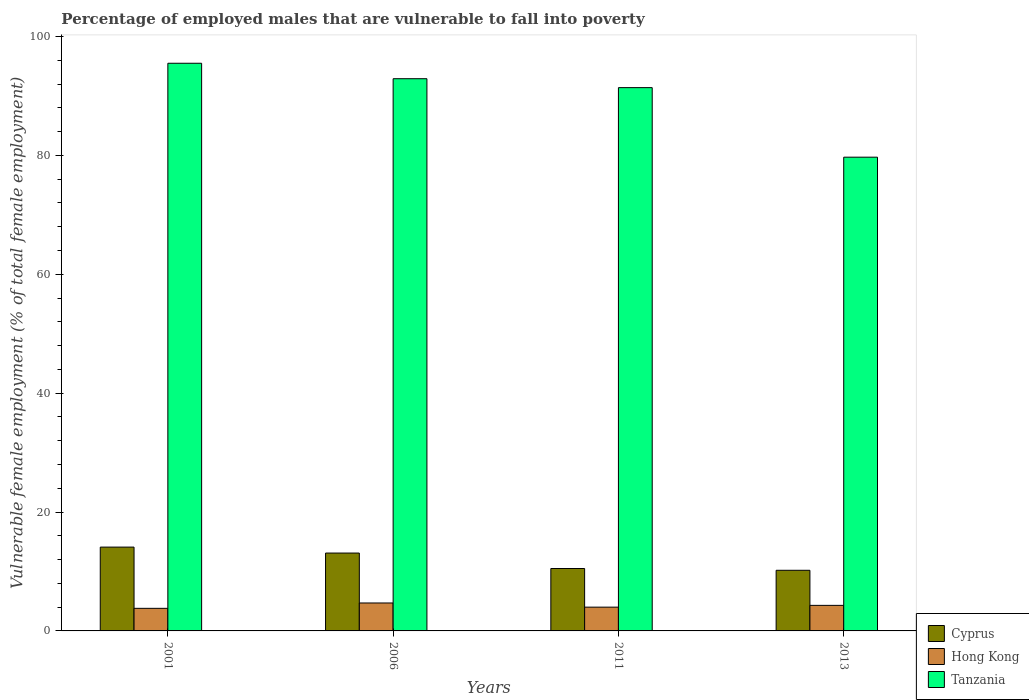How many different coloured bars are there?
Keep it short and to the point. 3. How many groups of bars are there?
Offer a terse response. 4. Are the number of bars on each tick of the X-axis equal?
Ensure brevity in your answer.  Yes. How many bars are there on the 3rd tick from the left?
Keep it short and to the point. 3. How many bars are there on the 4th tick from the right?
Provide a short and direct response. 3. What is the label of the 3rd group of bars from the left?
Offer a very short reply. 2011. In how many cases, is the number of bars for a given year not equal to the number of legend labels?
Give a very brief answer. 0. What is the percentage of employed males who are vulnerable to fall into poverty in Tanzania in 2013?
Give a very brief answer. 79.7. Across all years, what is the maximum percentage of employed males who are vulnerable to fall into poverty in Hong Kong?
Ensure brevity in your answer.  4.7. Across all years, what is the minimum percentage of employed males who are vulnerable to fall into poverty in Hong Kong?
Provide a succinct answer. 3.8. What is the total percentage of employed males who are vulnerable to fall into poverty in Cyprus in the graph?
Provide a succinct answer. 47.9. What is the difference between the percentage of employed males who are vulnerable to fall into poverty in Tanzania in 2006 and that in 2013?
Provide a succinct answer. 13.2. What is the difference between the percentage of employed males who are vulnerable to fall into poverty in Tanzania in 2006 and the percentage of employed males who are vulnerable to fall into poverty in Hong Kong in 2013?
Make the answer very short. 88.6. What is the average percentage of employed males who are vulnerable to fall into poverty in Cyprus per year?
Your answer should be compact. 11.98. In the year 2006, what is the difference between the percentage of employed males who are vulnerable to fall into poverty in Hong Kong and percentage of employed males who are vulnerable to fall into poverty in Tanzania?
Provide a short and direct response. -88.2. What is the ratio of the percentage of employed males who are vulnerable to fall into poverty in Hong Kong in 2011 to that in 2013?
Your answer should be compact. 0.93. Is the difference between the percentage of employed males who are vulnerable to fall into poverty in Hong Kong in 2001 and 2013 greater than the difference between the percentage of employed males who are vulnerable to fall into poverty in Tanzania in 2001 and 2013?
Offer a terse response. No. What is the difference between the highest and the second highest percentage of employed males who are vulnerable to fall into poverty in Hong Kong?
Offer a very short reply. 0.4. What is the difference between the highest and the lowest percentage of employed males who are vulnerable to fall into poverty in Hong Kong?
Your response must be concise. 0.9. Is the sum of the percentage of employed males who are vulnerable to fall into poverty in Hong Kong in 2006 and 2011 greater than the maximum percentage of employed males who are vulnerable to fall into poverty in Tanzania across all years?
Give a very brief answer. No. What does the 1st bar from the left in 2013 represents?
Your response must be concise. Cyprus. What does the 3rd bar from the right in 2011 represents?
Keep it short and to the point. Cyprus. Is it the case that in every year, the sum of the percentage of employed males who are vulnerable to fall into poverty in Tanzania and percentage of employed males who are vulnerable to fall into poverty in Cyprus is greater than the percentage of employed males who are vulnerable to fall into poverty in Hong Kong?
Your answer should be very brief. Yes. How many years are there in the graph?
Keep it short and to the point. 4. What is the difference between two consecutive major ticks on the Y-axis?
Provide a short and direct response. 20. Where does the legend appear in the graph?
Offer a terse response. Bottom right. How many legend labels are there?
Provide a succinct answer. 3. How are the legend labels stacked?
Provide a succinct answer. Vertical. What is the title of the graph?
Your response must be concise. Percentage of employed males that are vulnerable to fall into poverty. What is the label or title of the Y-axis?
Provide a succinct answer. Vulnerable female employment (% of total female employment). What is the Vulnerable female employment (% of total female employment) in Cyprus in 2001?
Your answer should be compact. 14.1. What is the Vulnerable female employment (% of total female employment) of Hong Kong in 2001?
Provide a short and direct response. 3.8. What is the Vulnerable female employment (% of total female employment) of Tanzania in 2001?
Your response must be concise. 95.5. What is the Vulnerable female employment (% of total female employment) in Cyprus in 2006?
Offer a very short reply. 13.1. What is the Vulnerable female employment (% of total female employment) in Hong Kong in 2006?
Keep it short and to the point. 4.7. What is the Vulnerable female employment (% of total female employment) in Tanzania in 2006?
Your response must be concise. 92.9. What is the Vulnerable female employment (% of total female employment) of Cyprus in 2011?
Offer a very short reply. 10.5. What is the Vulnerable female employment (% of total female employment) of Hong Kong in 2011?
Keep it short and to the point. 4. What is the Vulnerable female employment (% of total female employment) in Tanzania in 2011?
Give a very brief answer. 91.4. What is the Vulnerable female employment (% of total female employment) in Cyprus in 2013?
Your answer should be very brief. 10.2. What is the Vulnerable female employment (% of total female employment) of Hong Kong in 2013?
Provide a short and direct response. 4.3. What is the Vulnerable female employment (% of total female employment) of Tanzania in 2013?
Offer a very short reply. 79.7. Across all years, what is the maximum Vulnerable female employment (% of total female employment) of Cyprus?
Your response must be concise. 14.1. Across all years, what is the maximum Vulnerable female employment (% of total female employment) of Hong Kong?
Your answer should be compact. 4.7. Across all years, what is the maximum Vulnerable female employment (% of total female employment) in Tanzania?
Keep it short and to the point. 95.5. Across all years, what is the minimum Vulnerable female employment (% of total female employment) in Cyprus?
Provide a short and direct response. 10.2. Across all years, what is the minimum Vulnerable female employment (% of total female employment) in Hong Kong?
Your response must be concise. 3.8. Across all years, what is the minimum Vulnerable female employment (% of total female employment) in Tanzania?
Keep it short and to the point. 79.7. What is the total Vulnerable female employment (% of total female employment) of Cyprus in the graph?
Keep it short and to the point. 47.9. What is the total Vulnerable female employment (% of total female employment) of Hong Kong in the graph?
Keep it short and to the point. 16.8. What is the total Vulnerable female employment (% of total female employment) in Tanzania in the graph?
Provide a succinct answer. 359.5. What is the difference between the Vulnerable female employment (% of total female employment) in Hong Kong in 2001 and that in 2011?
Give a very brief answer. -0.2. What is the difference between the Vulnerable female employment (% of total female employment) of Cyprus in 2001 and that in 2013?
Keep it short and to the point. 3.9. What is the difference between the Vulnerable female employment (% of total female employment) in Tanzania in 2001 and that in 2013?
Your answer should be very brief. 15.8. What is the difference between the Vulnerable female employment (% of total female employment) of Hong Kong in 2006 and that in 2011?
Provide a short and direct response. 0.7. What is the difference between the Vulnerable female employment (% of total female employment) in Tanzania in 2006 and that in 2011?
Your answer should be very brief. 1.5. What is the difference between the Vulnerable female employment (% of total female employment) of Tanzania in 2006 and that in 2013?
Your response must be concise. 13.2. What is the difference between the Vulnerable female employment (% of total female employment) of Cyprus in 2011 and that in 2013?
Make the answer very short. 0.3. What is the difference between the Vulnerable female employment (% of total female employment) in Hong Kong in 2011 and that in 2013?
Your response must be concise. -0.3. What is the difference between the Vulnerable female employment (% of total female employment) in Cyprus in 2001 and the Vulnerable female employment (% of total female employment) in Hong Kong in 2006?
Keep it short and to the point. 9.4. What is the difference between the Vulnerable female employment (% of total female employment) of Cyprus in 2001 and the Vulnerable female employment (% of total female employment) of Tanzania in 2006?
Your answer should be compact. -78.8. What is the difference between the Vulnerable female employment (% of total female employment) in Hong Kong in 2001 and the Vulnerable female employment (% of total female employment) in Tanzania in 2006?
Your answer should be very brief. -89.1. What is the difference between the Vulnerable female employment (% of total female employment) of Cyprus in 2001 and the Vulnerable female employment (% of total female employment) of Tanzania in 2011?
Keep it short and to the point. -77.3. What is the difference between the Vulnerable female employment (% of total female employment) in Hong Kong in 2001 and the Vulnerable female employment (% of total female employment) in Tanzania in 2011?
Your answer should be very brief. -87.6. What is the difference between the Vulnerable female employment (% of total female employment) of Cyprus in 2001 and the Vulnerable female employment (% of total female employment) of Hong Kong in 2013?
Your answer should be compact. 9.8. What is the difference between the Vulnerable female employment (% of total female employment) in Cyprus in 2001 and the Vulnerable female employment (% of total female employment) in Tanzania in 2013?
Keep it short and to the point. -65.6. What is the difference between the Vulnerable female employment (% of total female employment) of Hong Kong in 2001 and the Vulnerable female employment (% of total female employment) of Tanzania in 2013?
Provide a succinct answer. -75.9. What is the difference between the Vulnerable female employment (% of total female employment) in Cyprus in 2006 and the Vulnerable female employment (% of total female employment) in Hong Kong in 2011?
Give a very brief answer. 9.1. What is the difference between the Vulnerable female employment (% of total female employment) of Cyprus in 2006 and the Vulnerable female employment (% of total female employment) of Tanzania in 2011?
Provide a succinct answer. -78.3. What is the difference between the Vulnerable female employment (% of total female employment) in Hong Kong in 2006 and the Vulnerable female employment (% of total female employment) in Tanzania in 2011?
Keep it short and to the point. -86.7. What is the difference between the Vulnerable female employment (% of total female employment) in Cyprus in 2006 and the Vulnerable female employment (% of total female employment) in Hong Kong in 2013?
Keep it short and to the point. 8.8. What is the difference between the Vulnerable female employment (% of total female employment) of Cyprus in 2006 and the Vulnerable female employment (% of total female employment) of Tanzania in 2013?
Your answer should be very brief. -66.6. What is the difference between the Vulnerable female employment (% of total female employment) of Hong Kong in 2006 and the Vulnerable female employment (% of total female employment) of Tanzania in 2013?
Your answer should be very brief. -75. What is the difference between the Vulnerable female employment (% of total female employment) in Cyprus in 2011 and the Vulnerable female employment (% of total female employment) in Tanzania in 2013?
Your response must be concise. -69.2. What is the difference between the Vulnerable female employment (% of total female employment) in Hong Kong in 2011 and the Vulnerable female employment (% of total female employment) in Tanzania in 2013?
Offer a terse response. -75.7. What is the average Vulnerable female employment (% of total female employment) in Cyprus per year?
Give a very brief answer. 11.97. What is the average Vulnerable female employment (% of total female employment) of Tanzania per year?
Your response must be concise. 89.88. In the year 2001, what is the difference between the Vulnerable female employment (% of total female employment) in Cyprus and Vulnerable female employment (% of total female employment) in Tanzania?
Ensure brevity in your answer.  -81.4. In the year 2001, what is the difference between the Vulnerable female employment (% of total female employment) of Hong Kong and Vulnerable female employment (% of total female employment) of Tanzania?
Your answer should be very brief. -91.7. In the year 2006, what is the difference between the Vulnerable female employment (% of total female employment) of Cyprus and Vulnerable female employment (% of total female employment) of Tanzania?
Your answer should be very brief. -79.8. In the year 2006, what is the difference between the Vulnerable female employment (% of total female employment) of Hong Kong and Vulnerable female employment (% of total female employment) of Tanzania?
Your answer should be compact. -88.2. In the year 2011, what is the difference between the Vulnerable female employment (% of total female employment) of Cyprus and Vulnerable female employment (% of total female employment) of Hong Kong?
Offer a very short reply. 6.5. In the year 2011, what is the difference between the Vulnerable female employment (% of total female employment) of Cyprus and Vulnerable female employment (% of total female employment) of Tanzania?
Provide a succinct answer. -80.9. In the year 2011, what is the difference between the Vulnerable female employment (% of total female employment) of Hong Kong and Vulnerable female employment (% of total female employment) of Tanzania?
Provide a short and direct response. -87.4. In the year 2013, what is the difference between the Vulnerable female employment (% of total female employment) of Cyprus and Vulnerable female employment (% of total female employment) of Tanzania?
Provide a succinct answer. -69.5. In the year 2013, what is the difference between the Vulnerable female employment (% of total female employment) of Hong Kong and Vulnerable female employment (% of total female employment) of Tanzania?
Your answer should be compact. -75.4. What is the ratio of the Vulnerable female employment (% of total female employment) in Cyprus in 2001 to that in 2006?
Your answer should be very brief. 1.08. What is the ratio of the Vulnerable female employment (% of total female employment) of Hong Kong in 2001 to that in 2006?
Ensure brevity in your answer.  0.81. What is the ratio of the Vulnerable female employment (% of total female employment) of Tanzania in 2001 to that in 2006?
Make the answer very short. 1.03. What is the ratio of the Vulnerable female employment (% of total female employment) in Cyprus in 2001 to that in 2011?
Ensure brevity in your answer.  1.34. What is the ratio of the Vulnerable female employment (% of total female employment) in Hong Kong in 2001 to that in 2011?
Keep it short and to the point. 0.95. What is the ratio of the Vulnerable female employment (% of total female employment) of Tanzania in 2001 to that in 2011?
Offer a very short reply. 1.04. What is the ratio of the Vulnerable female employment (% of total female employment) of Cyprus in 2001 to that in 2013?
Give a very brief answer. 1.38. What is the ratio of the Vulnerable female employment (% of total female employment) of Hong Kong in 2001 to that in 2013?
Ensure brevity in your answer.  0.88. What is the ratio of the Vulnerable female employment (% of total female employment) of Tanzania in 2001 to that in 2013?
Your answer should be very brief. 1.2. What is the ratio of the Vulnerable female employment (% of total female employment) in Cyprus in 2006 to that in 2011?
Provide a succinct answer. 1.25. What is the ratio of the Vulnerable female employment (% of total female employment) in Hong Kong in 2006 to that in 2011?
Your answer should be compact. 1.18. What is the ratio of the Vulnerable female employment (% of total female employment) in Tanzania in 2006 to that in 2011?
Your response must be concise. 1.02. What is the ratio of the Vulnerable female employment (% of total female employment) in Cyprus in 2006 to that in 2013?
Your answer should be very brief. 1.28. What is the ratio of the Vulnerable female employment (% of total female employment) in Hong Kong in 2006 to that in 2013?
Your answer should be very brief. 1.09. What is the ratio of the Vulnerable female employment (% of total female employment) of Tanzania in 2006 to that in 2013?
Make the answer very short. 1.17. What is the ratio of the Vulnerable female employment (% of total female employment) of Cyprus in 2011 to that in 2013?
Keep it short and to the point. 1.03. What is the ratio of the Vulnerable female employment (% of total female employment) in Hong Kong in 2011 to that in 2013?
Give a very brief answer. 0.93. What is the ratio of the Vulnerable female employment (% of total female employment) of Tanzania in 2011 to that in 2013?
Make the answer very short. 1.15. What is the difference between the highest and the second highest Vulnerable female employment (% of total female employment) of Cyprus?
Your response must be concise. 1. What is the difference between the highest and the second highest Vulnerable female employment (% of total female employment) of Hong Kong?
Give a very brief answer. 0.4. What is the difference between the highest and the second highest Vulnerable female employment (% of total female employment) in Tanzania?
Provide a succinct answer. 2.6. 